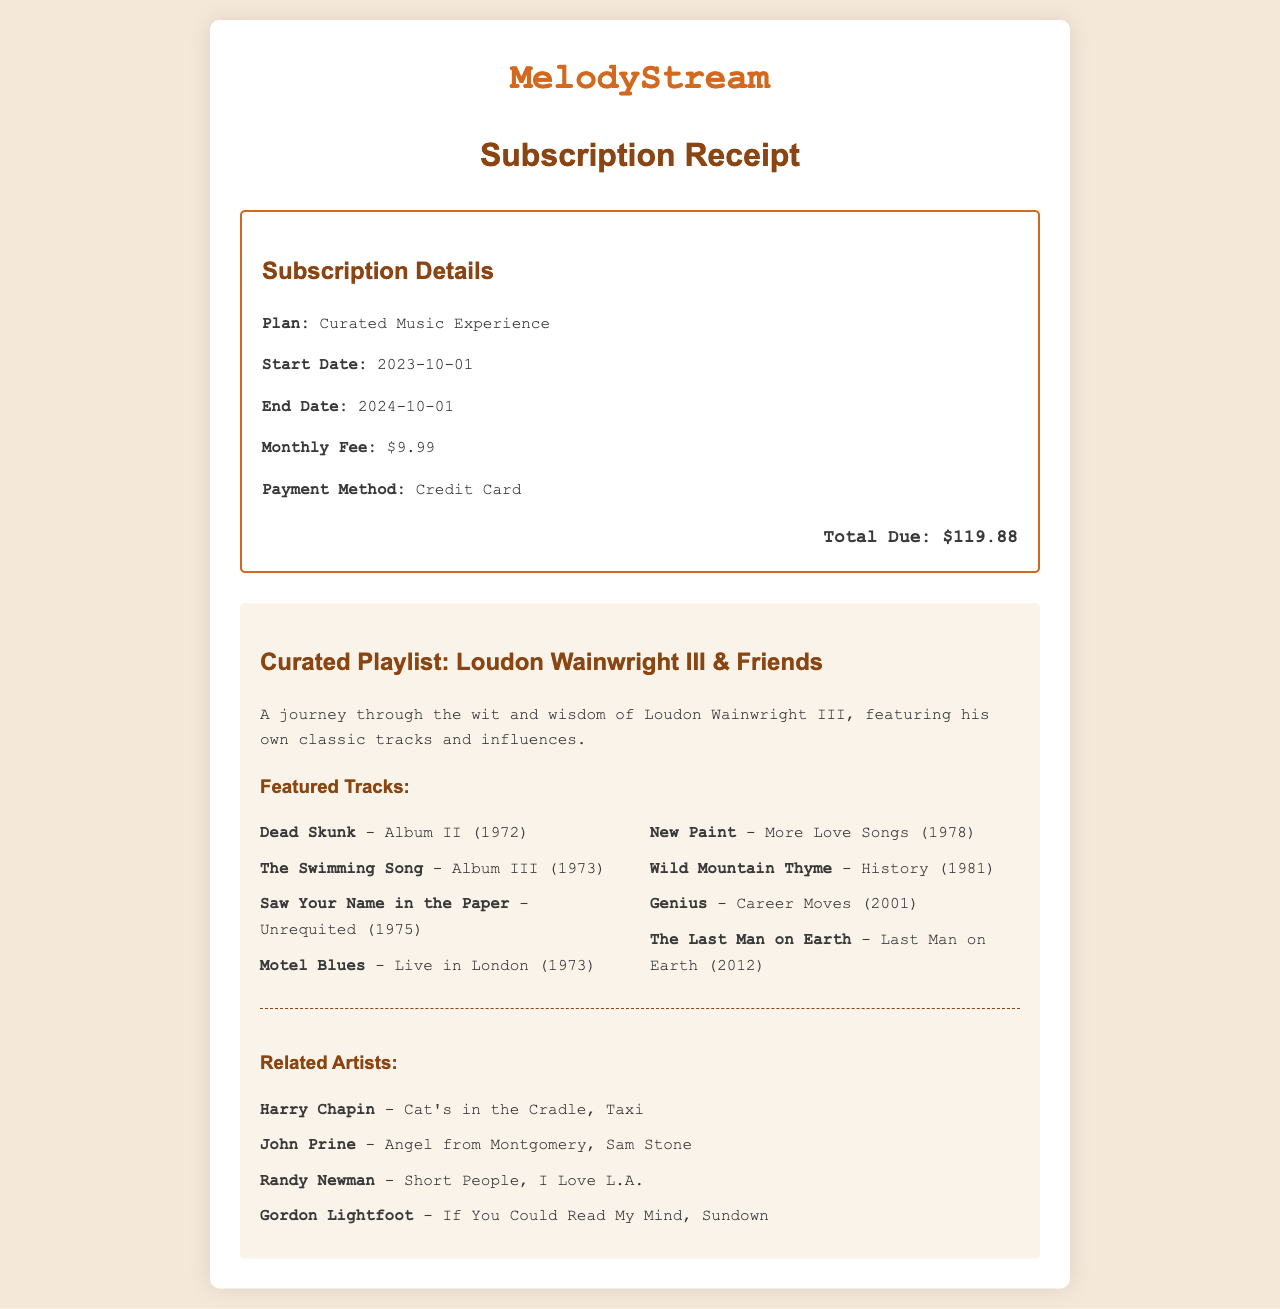What is the name of the music streaming service? The name of the service is prominently displayed at the top of the receipt.
Answer: MelodyStream What is the subscription plan? The subscription plan is mentioned in the receipt details section.
Answer: Curated Music Experience What is the monthly fee? The monthly fee is listed under subscription details.
Answer: $9.99 When does the subscription end? The end date of the subscription is provided in the receipt details.
Answer: 2024-10-01 Name one featured track by Loudon Wainwright III. The featured tracks include titles of songs from the curated playlist.
Answer: Dead Skunk How many related artists are listed? The number of related artists can be counted in the related artists section.
Answer: 4 What is the total amount due? The total amount due is clearly stated at the bottom of the receipt.
Answer: $119.88 Which album features the track "The Swimming Song"? The album for the mentioned track can be found next to the song title.
Answer: Album III Who is one of the related artists? The related artists are listed in the receipts, allowing for a selection from that list.
Answer: Harry Chapin 